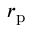<formula> <loc_0><loc_0><loc_500><loc_500>r _ { p }</formula> 